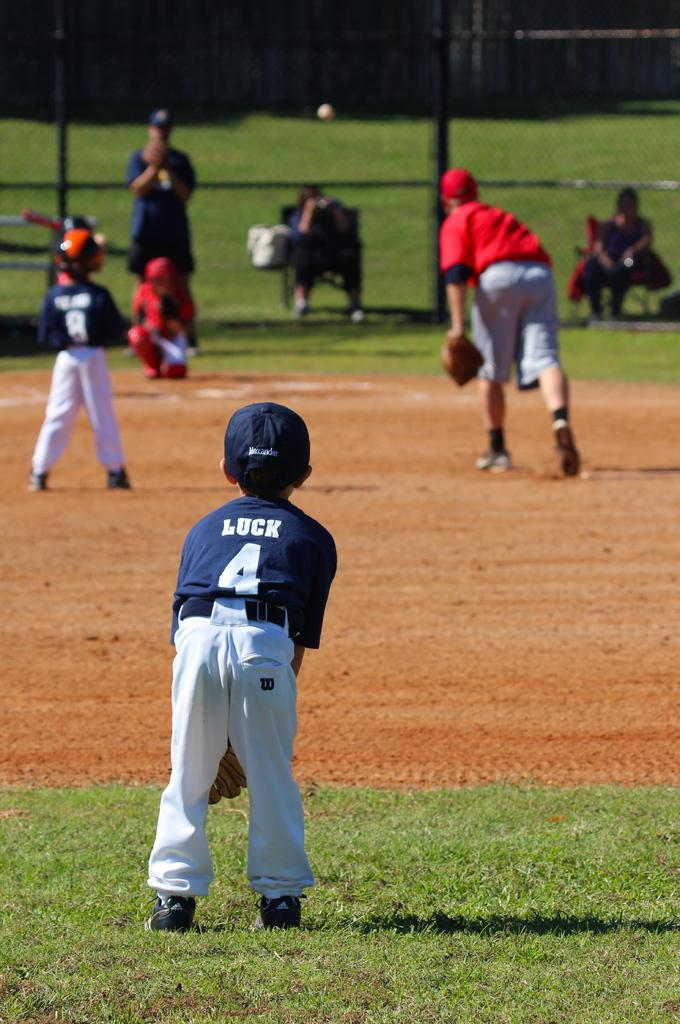<image>
Render a clear and concise summary of the photo. a player that has the number 4 on their back 